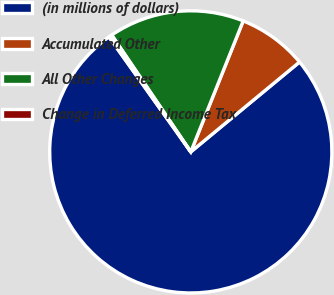<chart> <loc_0><loc_0><loc_500><loc_500><pie_chart><fcel>(in millions of dollars)<fcel>Accumulated Other<fcel>All Other Changes<fcel>Change in Deferred Income Tax<nl><fcel>76.16%<fcel>7.95%<fcel>15.53%<fcel>0.37%<nl></chart> 